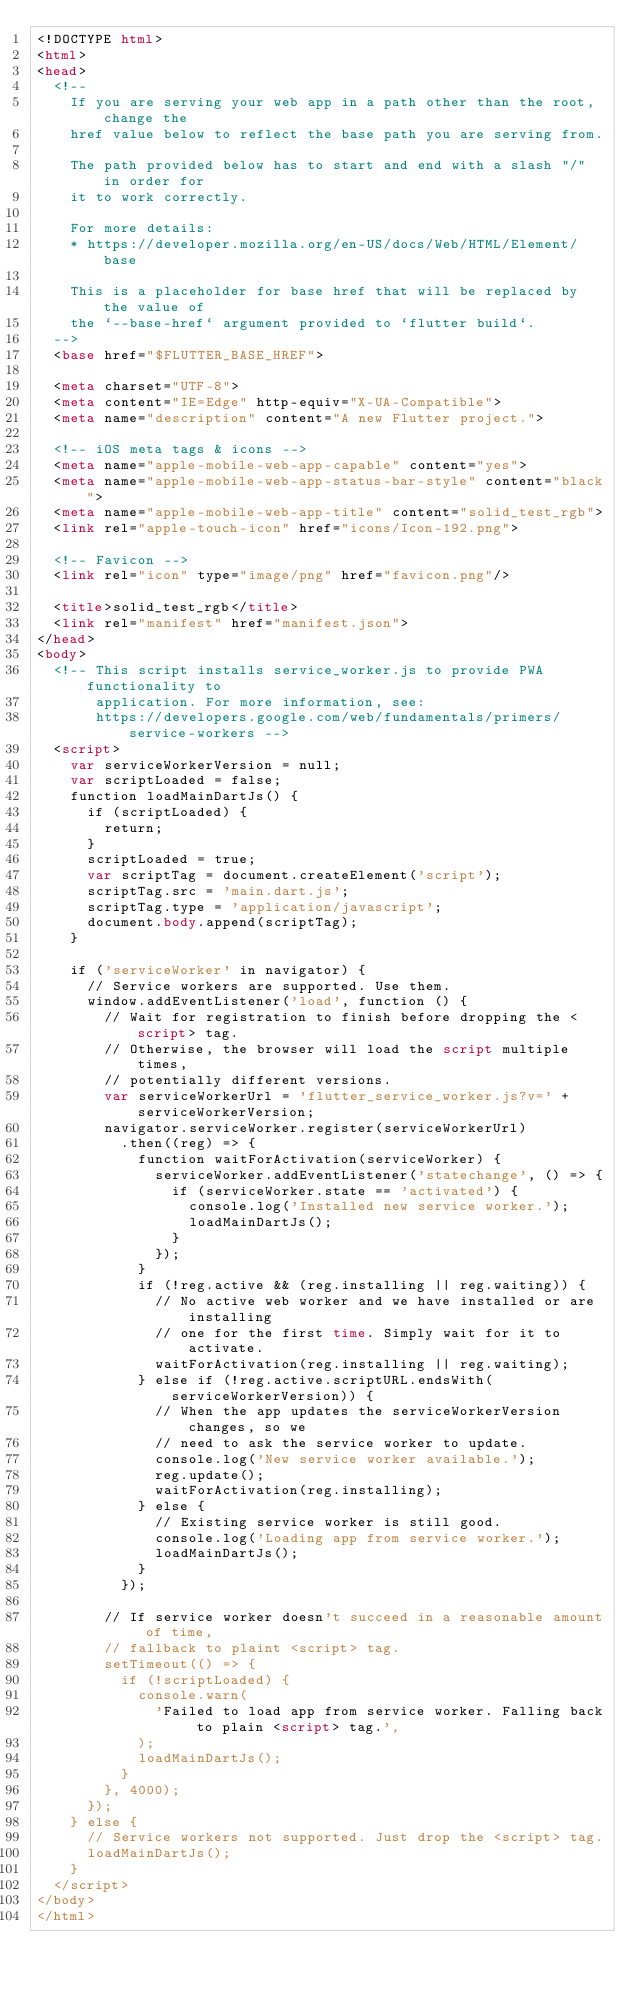<code> <loc_0><loc_0><loc_500><loc_500><_HTML_><!DOCTYPE html>
<html>
<head>
  <!--
    If you are serving your web app in a path other than the root, change the
    href value below to reflect the base path you are serving from.

    The path provided below has to start and end with a slash "/" in order for
    it to work correctly.

    For more details:
    * https://developer.mozilla.org/en-US/docs/Web/HTML/Element/base

    This is a placeholder for base href that will be replaced by the value of
    the `--base-href` argument provided to `flutter build`.
  -->
  <base href="$FLUTTER_BASE_HREF">

  <meta charset="UTF-8">
  <meta content="IE=Edge" http-equiv="X-UA-Compatible">
  <meta name="description" content="A new Flutter project.">

  <!-- iOS meta tags & icons -->
  <meta name="apple-mobile-web-app-capable" content="yes">
  <meta name="apple-mobile-web-app-status-bar-style" content="black">
  <meta name="apple-mobile-web-app-title" content="solid_test_rgb">
  <link rel="apple-touch-icon" href="icons/Icon-192.png">

  <!-- Favicon -->
  <link rel="icon" type="image/png" href="favicon.png"/>

  <title>solid_test_rgb</title>
  <link rel="manifest" href="manifest.json">
</head>
<body>
  <!-- This script installs service_worker.js to provide PWA functionality to
       application. For more information, see:
       https://developers.google.com/web/fundamentals/primers/service-workers -->
  <script>
    var serviceWorkerVersion = null;
    var scriptLoaded = false;
    function loadMainDartJs() {
      if (scriptLoaded) {
        return;
      }
      scriptLoaded = true;
      var scriptTag = document.createElement('script');
      scriptTag.src = 'main.dart.js';
      scriptTag.type = 'application/javascript';
      document.body.append(scriptTag);
    }

    if ('serviceWorker' in navigator) {
      // Service workers are supported. Use them.
      window.addEventListener('load', function () {
        // Wait for registration to finish before dropping the <script> tag.
        // Otherwise, the browser will load the script multiple times,
        // potentially different versions.
        var serviceWorkerUrl = 'flutter_service_worker.js?v=' + serviceWorkerVersion;
        navigator.serviceWorker.register(serviceWorkerUrl)
          .then((reg) => {
            function waitForActivation(serviceWorker) {
              serviceWorker.addEventListener('statechange', () => {
                if (serviceWorker.state == 'activated') {
                  console.log('Installed new service worker.');
                  loadMainDartJs();
                }
              });
            }
            if (!reg.active && (reg.installing || reg.waiting)) {
              // No active web worker and we have installed or are installing
              // one for the first time. Simply wait for it to activate.
              waitForActivation(reg.installing || reg.waiting);
            } else if (!reg.active.scriptURL.endsWith(serviceWorkerVersion)) {
              // When the app updates the serviceWorkerVersion changes, so we
              // need to ask the service worker to update.
              console.log('New service worker available.');
              reg.update();
              waitForActivation(reg.installing);
            } else {
              // Existing service worker is still good.
              console.log('Loading app from service worker.');
              loadMainDartJs();
            }
          });

        // If service worker doesn't succeed in a reasonable amount of time,
        // fallback to plaint <script> tag.
        setTimeout(() => {
          if (!scriptLoaded) {
            console.warn(
              'Failed to load app from service worker. Falling back to plain <script> tag.',
            );
            loadMainDartJs();
          }
        }, 4000);
      });
    } else {
      // Service workers not supported. Just drop the <script> tag.
      loadMainDartJs();
    }
  </script>
</body>
</html>
</code> 